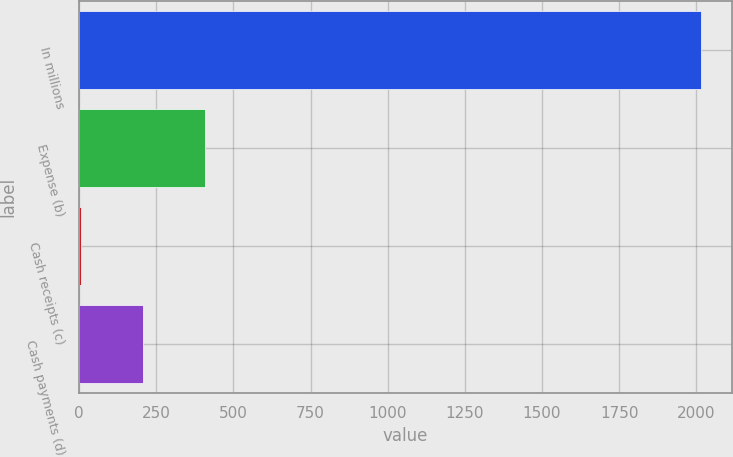<chart> <loc_0><loc_0><loc_500><loc_500><bar_chart><fcel>In millions<fcel>Expense (b)<fcel>Cash receipts (c)<fcel>Cash payments (d)<nl><fcel>2014<fcel>408.4<fcel>7<fcel>207.7<nl></chart> 